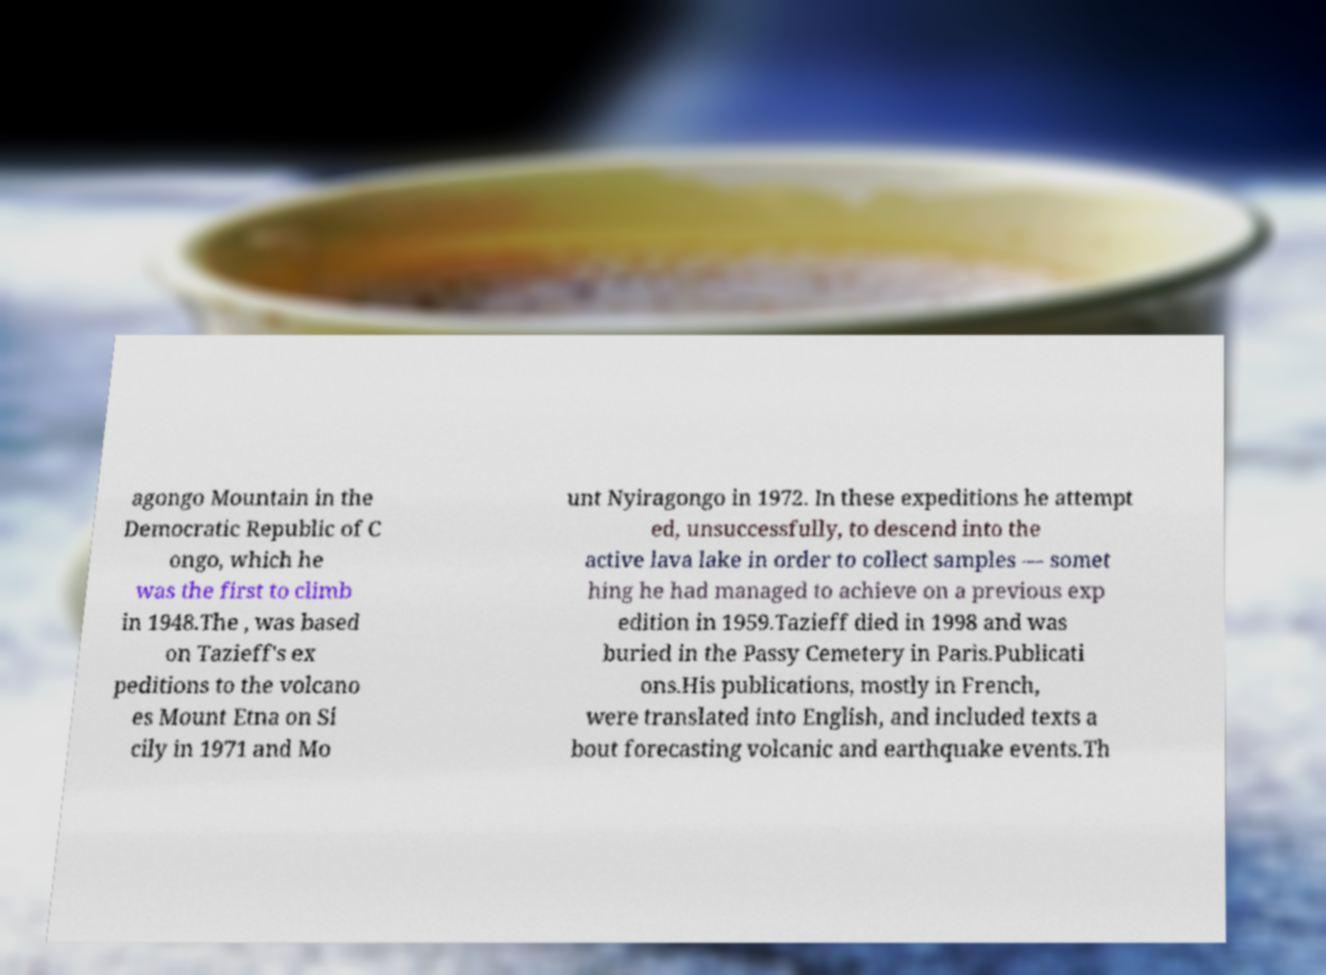Can you accurately transcribe the text from the provided image for me? agongo Mountain in the Democratic Republic of C ongo, which he was the first to climb in 1948.The , was based on Tazieff's ex peditions to the volcano es Mount Etna on Si cily in 1971 and Mo unt Nyiragongo in 1972. In these expeditions he attempt ed, unsuccessfully, to descend into the active lava lake in order to collect samples — somet hing he had managed to achieve on a previous exp edition in 1959.Tazieff died in 1998 and was buried in the Passy Cemetery in Paris.Publicati ons.His publications, mostly in French, were translated into English, and included texts a bout forecasting volcanic and earthquake events.Th 